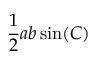Convert formula to latex. <formula><loc_0><loc_0><loc_500><loc_500>{ \frac { 1 } { 2 } } a b \sin ( C ) \,</formula> 